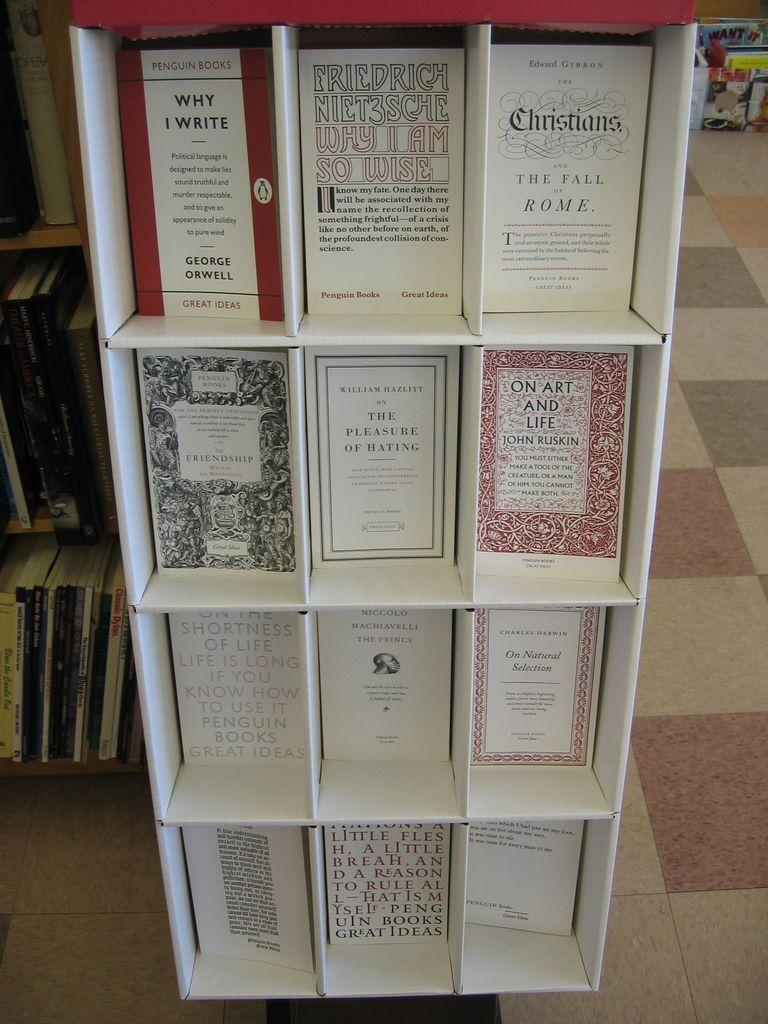<image>
Present a compact description of the photo's key features. A cardboard shelf holding various authors Penguin Books. 